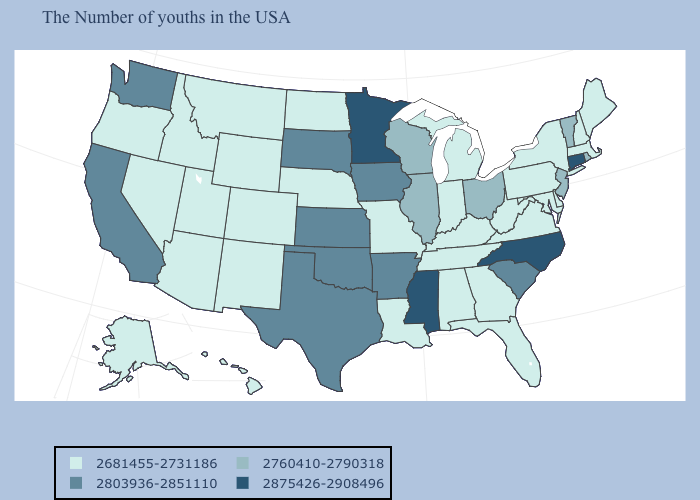Does Mississippi have the highest value in the South?
Write a very short answer. Yes. Name the states that have a value in the range 2760410-2790318?
Keep it brief. Rhode Island, Vermont, New Jersey, Ohio, Wisconsin, Illinois. Name the states that have a value in the range 2803936-2851110?
Be succinct. South Carolina, Arkansas, Iowa, Kansas, Oklahoma, Texas, South Dakota, California, Washington. Does North Dakota have the highest value in the USA?
Keep it brief. No. Name the states that have a value in the range 2760410-2790318?
Concise answer only. Rhode Island, Vermont, New Jersey, Ohio, Wisconsin, Illinois. What is the value of Florida?
Write a very short answer. 2681455-2731186. How many symbols are there in the legend?
Keep it brief. 4. Which states have the highest value in the USA?
Write a very short answer. Connecticut, North Carolina, Mississippi, Minnesota. What is the value of New Hampshire?
Keep it brief. 2681455-2731186. What is the value of Washington?
Be succinct. 2803936-2851110. Name the states that have a value in the range 2803936-2851110?
Quick response, please. South Carolina, Arkansas, Iowa, Kansas, Oklahoma, Texas, South Dakota, California, Washington. Does Kansas have the lowest value in the USA?
Be succinct. No. Does Delaware have the highest value in the South?
Concise answer only. No. Name the states that have a value in the range 2681455-2731186?
Write a very short answer. Maine, Massachusetts, New Hampshire, New York, Delaware, Maryland, Pennsylvania, Virginia, West Virginia, Florida, Georgia, Michigan, Kentucky, Indiana, Alabama, Tennessee, Louisiana, Missouri, Nebraska, North Dakota, Wyoming, Colorado, New Mexico, Utah, Montana, Arizona, Idaho, Nevada, Oregon, Alaska, Hawaii. Does Connecticut have the lowest value in the USA?
Answer briefly. No. 